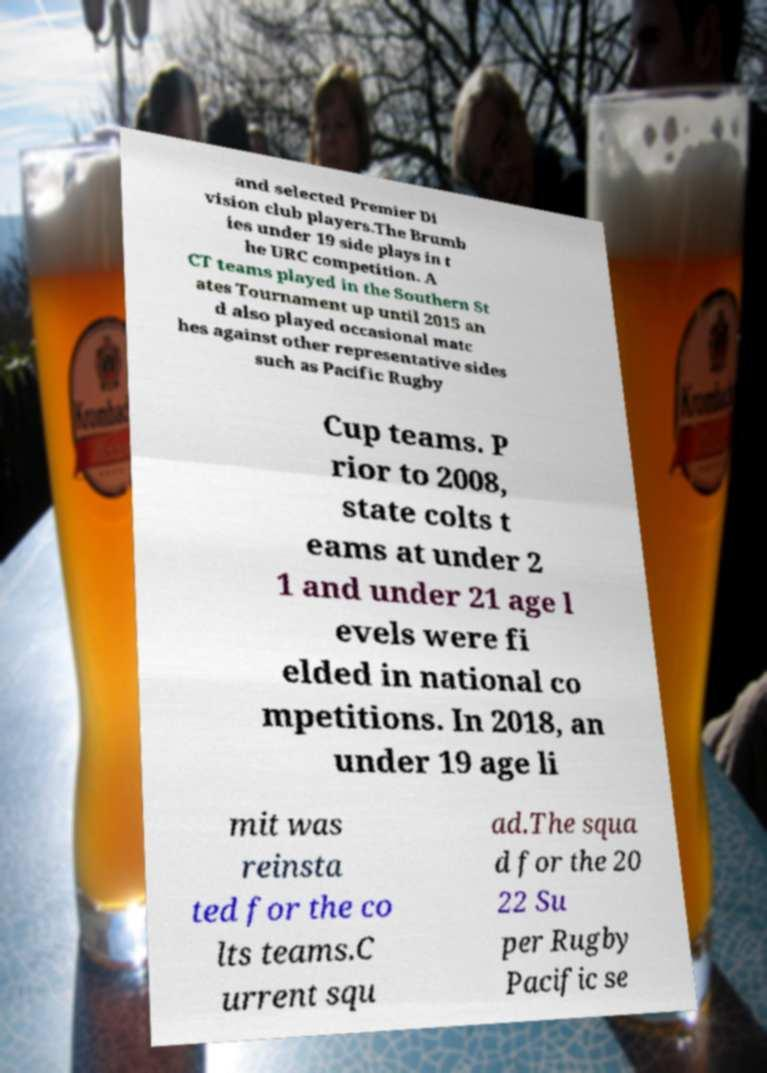Could you assist in decoding the text presented in this image and type it out clearly? and selected Premier Di vision club players.The Brumb ies under 19 side plays in t he URC competition. A CT teams played in the Southern St ates Tournament up until 2015 an d also played occasional matc hes against other representative sides such as Pacific Rugby Cup teams. P rior to 2008, state colts t eams at under 2 1 and under 21 age l evels were fi elded in national co mpetitions. In 2018, an under 19 age li mit was reinsta ted for the co lts teams.C urrent squ ad.The squa d for the 20 22 Su per Rugby Pacific se 